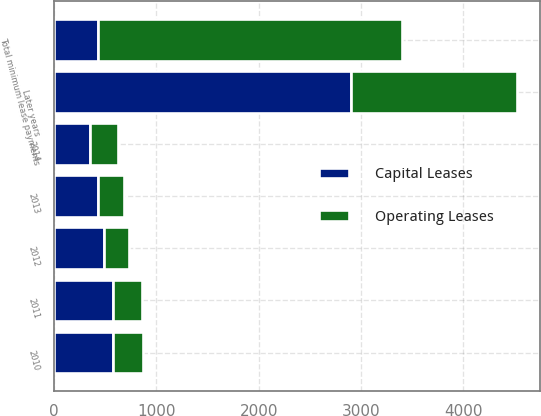<chart> <loc_0><loc_0><loc_500><loc_500><stacked_bar_chart><ecel><fcel>2010<fcel>2011<fcel>2012<fcel>2013<fcel>2014<fcel>Later years<fcel>Total minimum lease payments<nl><fcel>Capital Leases<fcel>576<fcel>570<fcel>488<fcel>425<fcel>352<fcel>2901<fcel>425<nl><fcel>Operating Leases<fcel>290<fcel>292<fcel>247<fcel>256<fcel>267<fcel>1623<fcel>2975<nl></chart> 